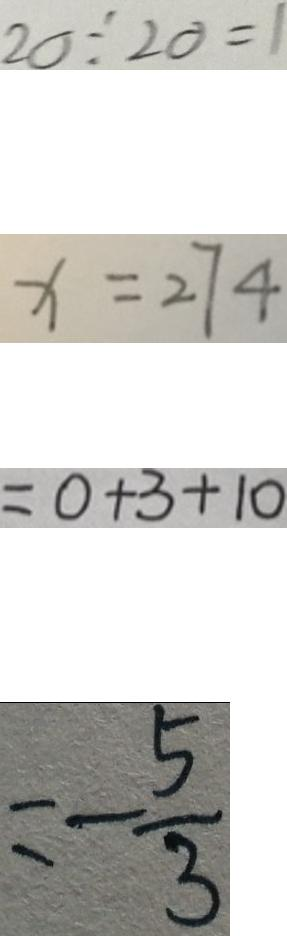Convert formula to latex. <formula><loc_0><loc_0><loc_500><loc_500>2 0 \div 2 0 = 1 
 x = 2 7 4 
 = 0 + 3 + 1 0 
 = - \frac { 5 } { 3 }</formula> 